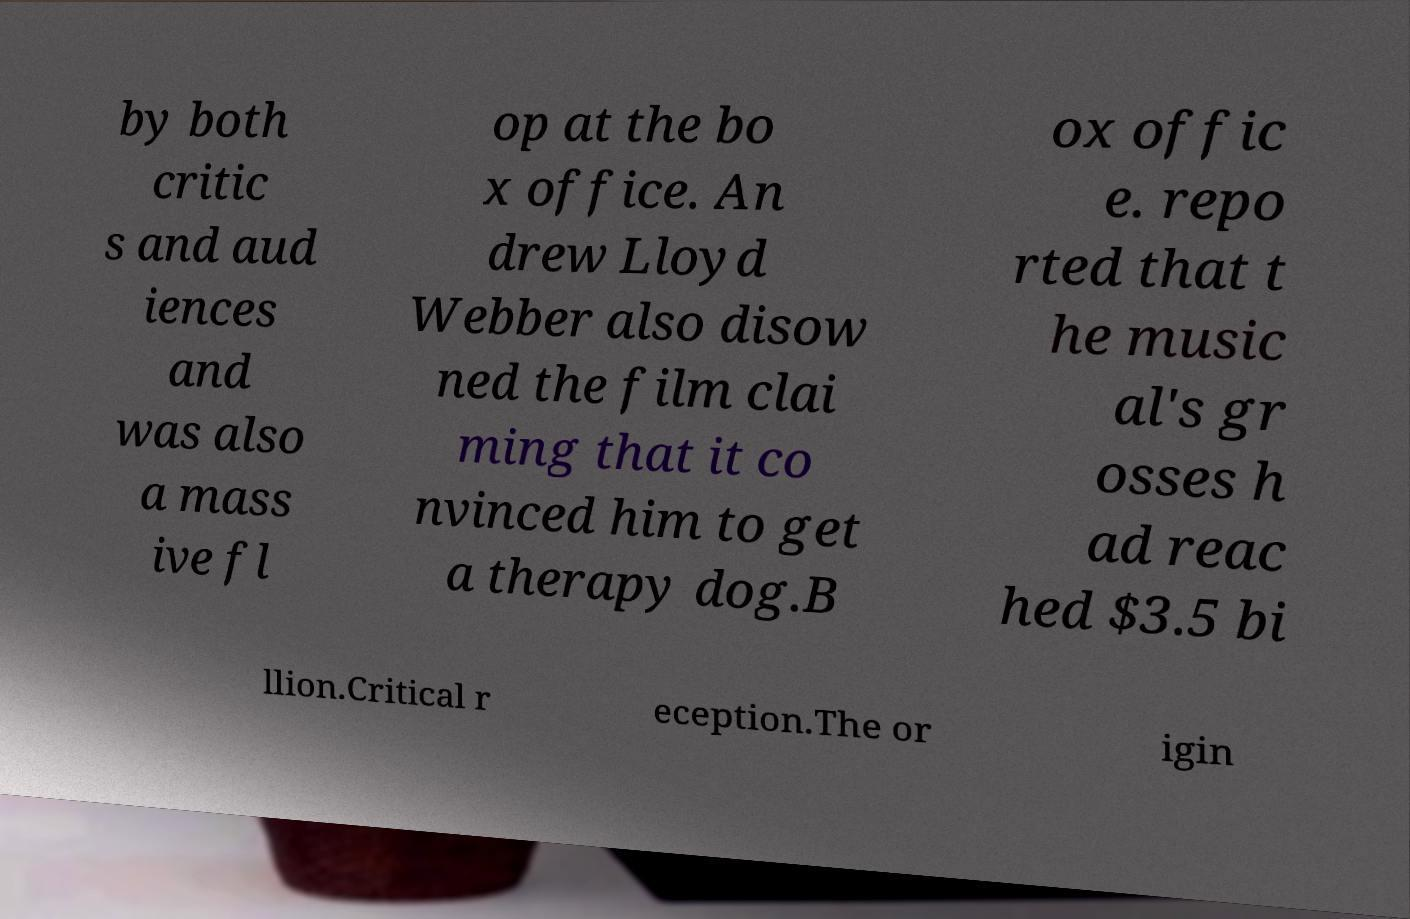For documentation purposes, I need the text within this image transcribed. Could you provide that? by both critic s and aud iences and was also a mass ive fl op at the bo x office. An drew Lloyd Webber also disow ned the film clai ming that it co nvinced him to get a therapy dog.B ox offic e. repo rted that t he music al's gr osses h ad reac hed $3.5 bi llion.Critical r eception.The or igin 